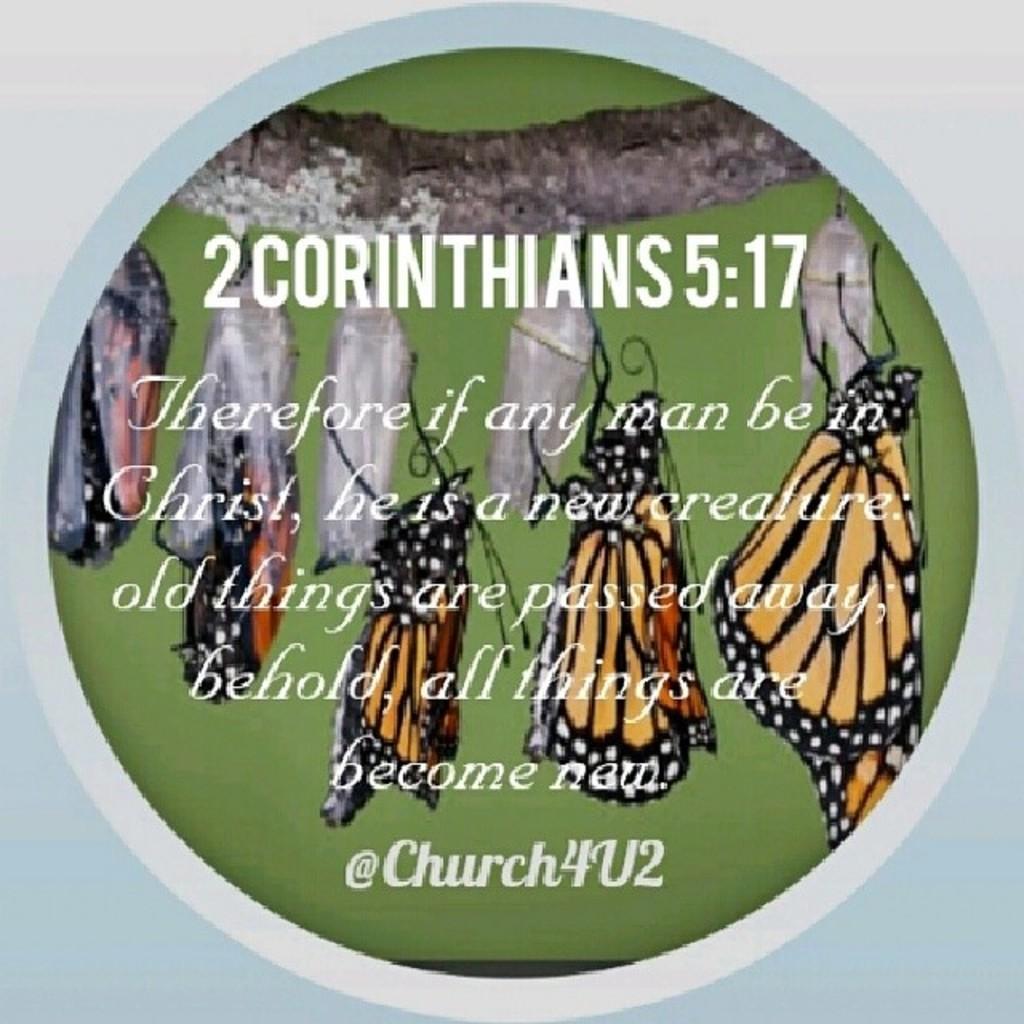How would you summarize this image in a sentence or two? This is a poster. In this poster there are butterflies and there is text. 